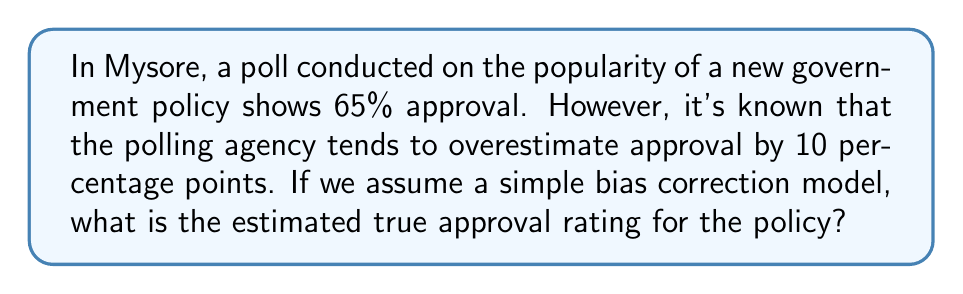Provide a solution to this math problem. To estimate the true public opinion from biased poll data, we need to apply a correction to the reported results. In this case, we'll use a simple bias correction model.

Step 1: Identify the reported approval rating and the known bias.
Reported approval rating: 65%
Known bias: +10 percentage points (overestimation)

Step 2: Set up the equation to correct for the bias.
Let $x$ be the true approval rating.
$$x + 10 = 65$$

Step 3: Solve for $x$ by subtracting the bias from the reported rating.
$$x = 65 - 10 = 55$$

Therefore, the estimated true approval rating for the policy is 55%.

This simple bias correction assumes a constant bias across all levels of approval. In practice, more sophisticated models might be used to account for varying biases at different approval levels or other factors influencing poll results.
Answer: 55% 